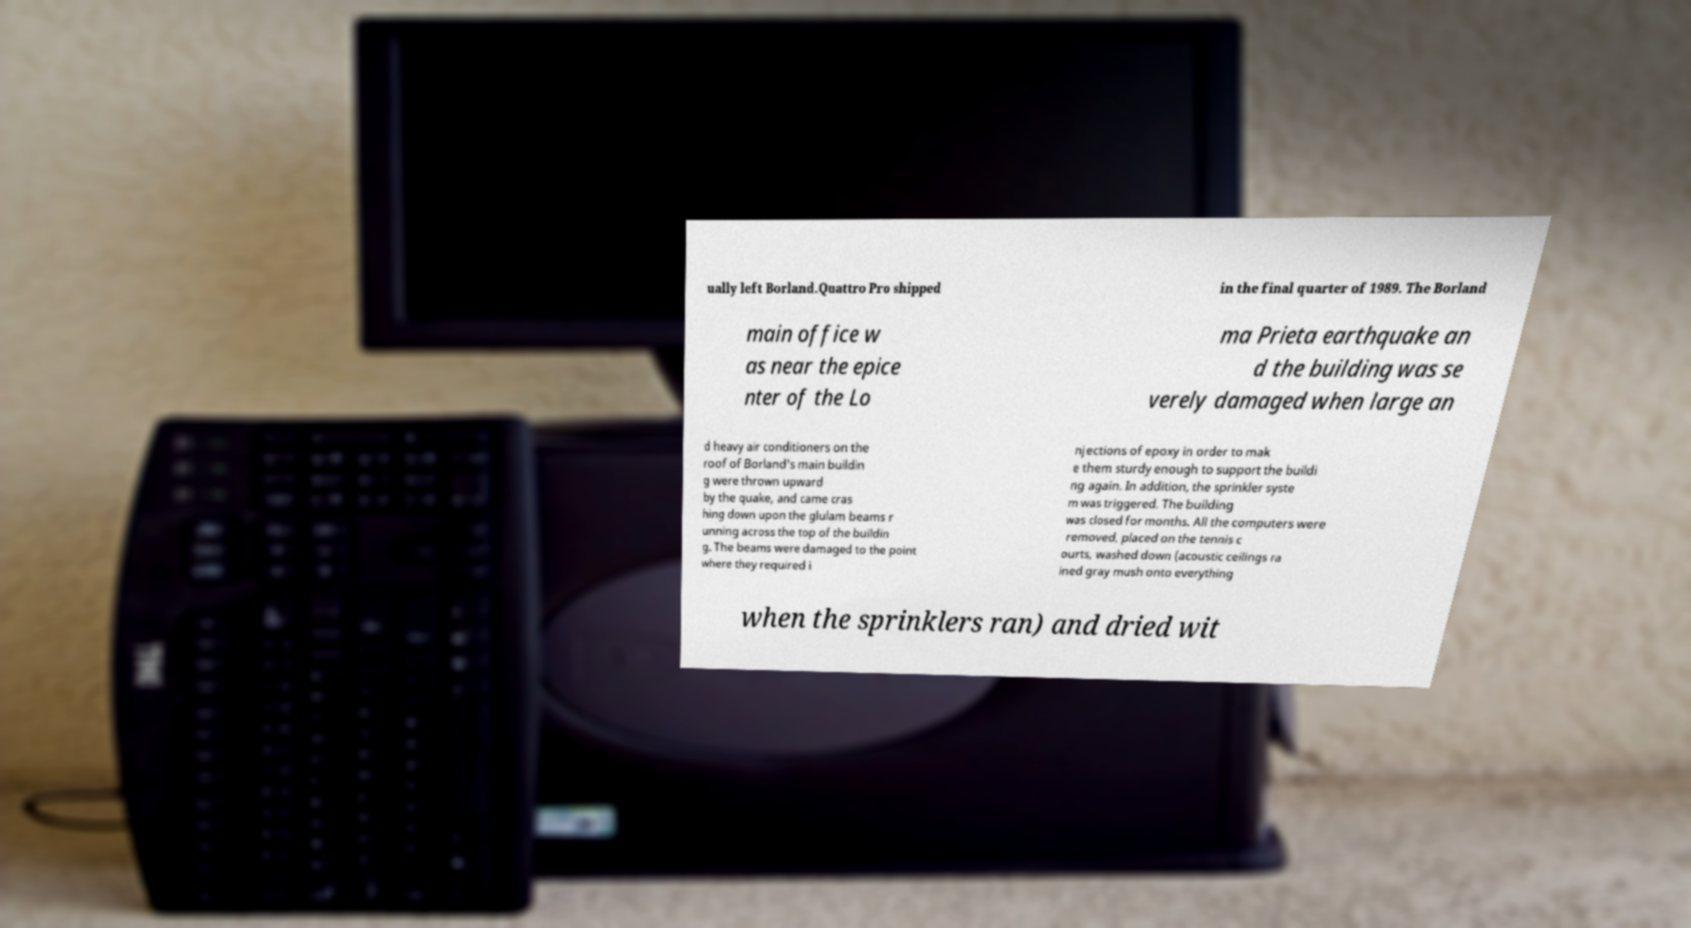Can you accurately transcribe the text from the provided image for me? ually left Borland.Quattro Pro shipped in the final quarter of 1989. The Borland main office w as near the epice nter of the Lo ma Prieta earthquake an d the building was se verely damaged when large an d heavy air conditioners on the roof of Borland's main buildin g were thrown upward by the quake, and came cras hing down upon the glulam beams r unning across the top of the buildin g. The beams were damaged to the point where they required i njections of epoxy in order to mak e them sturdy enough to support the buildi ng again. In addition, the sprinkler syste m was triggered. The building was closed for months. All the computers were removed, placed on the tennis c ourts, washed down (acoustic ceilings ra ined gray mush onto everything when the sprinklers ran) and dried wit 